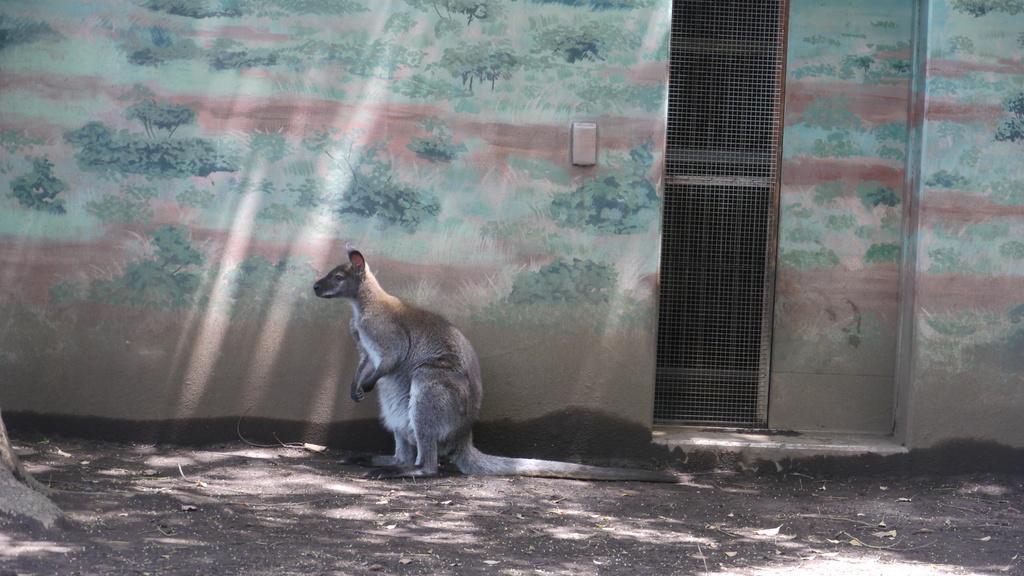Could you give a brief overview of what you see in this image? This is a kangaroo standing. I think this is a building wall with the wall painting. This looks like a fence sheet. 